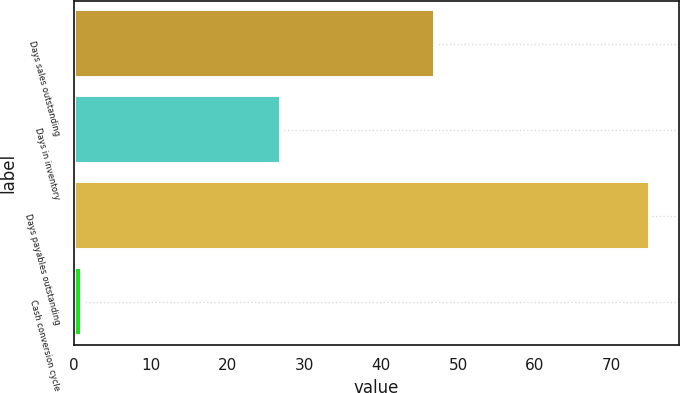Convert chart. <chart><loc_0><loc_0><loc_500><loc_500><bar_chart><fcel>Days sales outstanding<fcel>Days in inventory<fcel>Days payables outstanding<fcel>Cash conversion cycle<nl><fcel>47<fcel>27<fcel>75<fcel>1<nl></chart> 